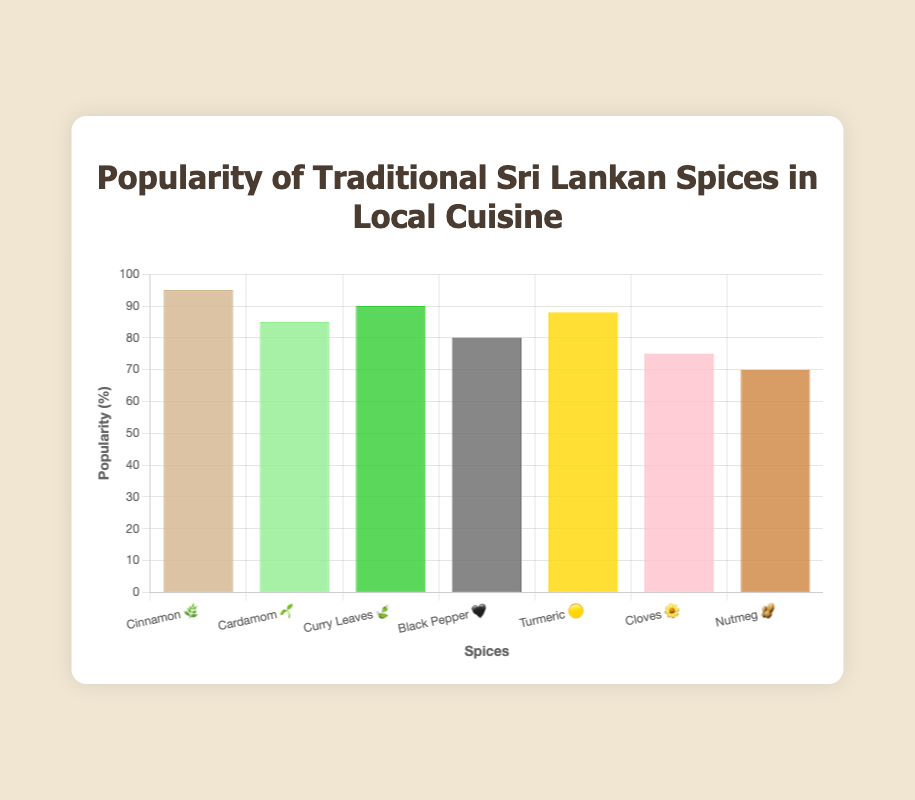What is the most popular spice in traditional Sri Lankan cuisine? The chart shows the popularity percentages for various spices. Cinnamon has the highest popularity with 95%.
Answer: Cinnamon What is the least popular spice in the chart? The chart shows the popularity percentages for various spices. Nutmeg has the lowest popularity with 70%.
Answer: Nutmeg How much more popular is Cinnamon compared to Black Pepper? Cinnamon has a popularity of 95%, and Black Pepper has 80%. The difference is 95 - 80 = 15%.
Answer: 15% Which spice has a popularity of 88%? According to the chart, Turmeric has a popularity of 88%.
Answer: Turmeric What's the total popularity of Cardamom and Cloves combined? Cardamom has a popularity of 85%, and Cloves have 75%. The total is 85 + 75 = 160%.
Answer: 160% Which spice has the closest popularity to Curry Leaves? The chart shows that Curry Leaves have a popularity of 90%. The spice closest in popularity is Turmeric, with 88%.
Answer: Turmeric Arrange the spices in descending order of their popularity. The spices ordered from most to least popular are: Cinnamon (95%), Curry Leaves (90%), Turmeric (88%), Cardamom (85%), Black Pepper (80%), Cloves (75%), Nutmeg (70%).
Answer: Cinnamon, Curry Leaves, Turmeric, Cardamom, Black Pepper, Cloves, Nutmeg What is the average popularity of all the spices? Sum up all the popularity values and divide by the number of spices: (95 + 85 + 90 + 80 + 88 + 75 + 70) / 7 ≈ 83.3%.
Answer: 83.3% Which spice is represented by the 🥜 emoji, and what is its popularity? The chart shows Nutmeg with the 🥜 emoji and a popularity of 70%.
Answer: Nutmeg, 70% In the chart, which spice is represented by the 🌼 emoji? The chart shows that Cloves are represented by the 🌼 emoji.
Answer: Cloves 